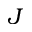<formula> <loc_0><loc_0><loc_500><loc_500>{ J }</formula> 